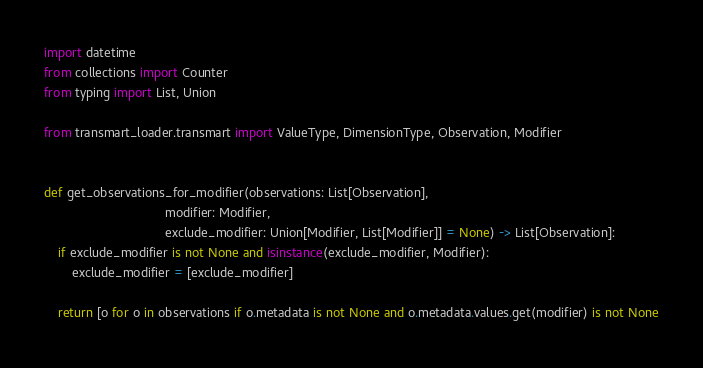Convert code to text. <code><loc_0><loc_0><loc_500><loc_500><_Python_>import datetime
from collections import Counter
from typing import List, Union

from transmart_loader.transmart import ValueType, DimensionType, Observation, Modifier


def get_observations_for_modifier(observations: List[Observation],
                                  modifier: Modifier,
                                  exclude_modifier: Union[Modifier, List[Modifier]] = None) -> List[Observation]:
    if exclude_modifier is not None and isinstance(exclude_modifier, Modifier):
        exclude_modifier = [exclude_modifier]

    return [o for o in observations if o.metadata is not None and o.metadata.values.get(modifier) is not None</code> 